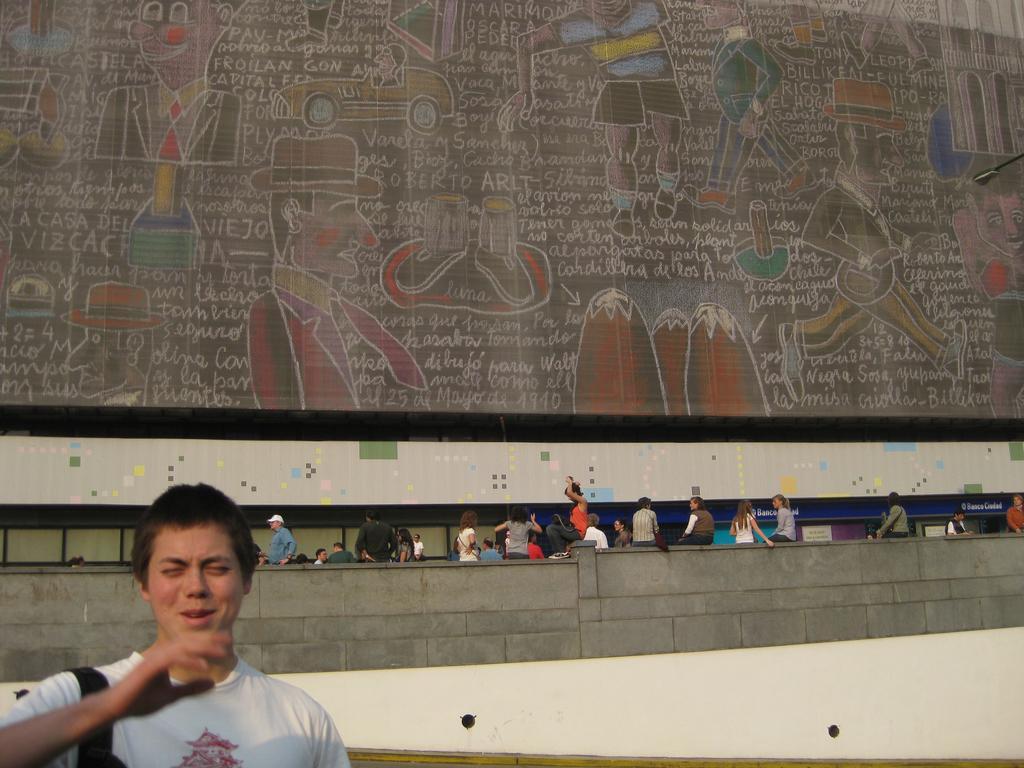Could you give a brief overview of what you see in this image? In this image I can see group of people. Back I can see few people,vehicles,some objects and something is written on it. In front I can see a person wearing white color top. 